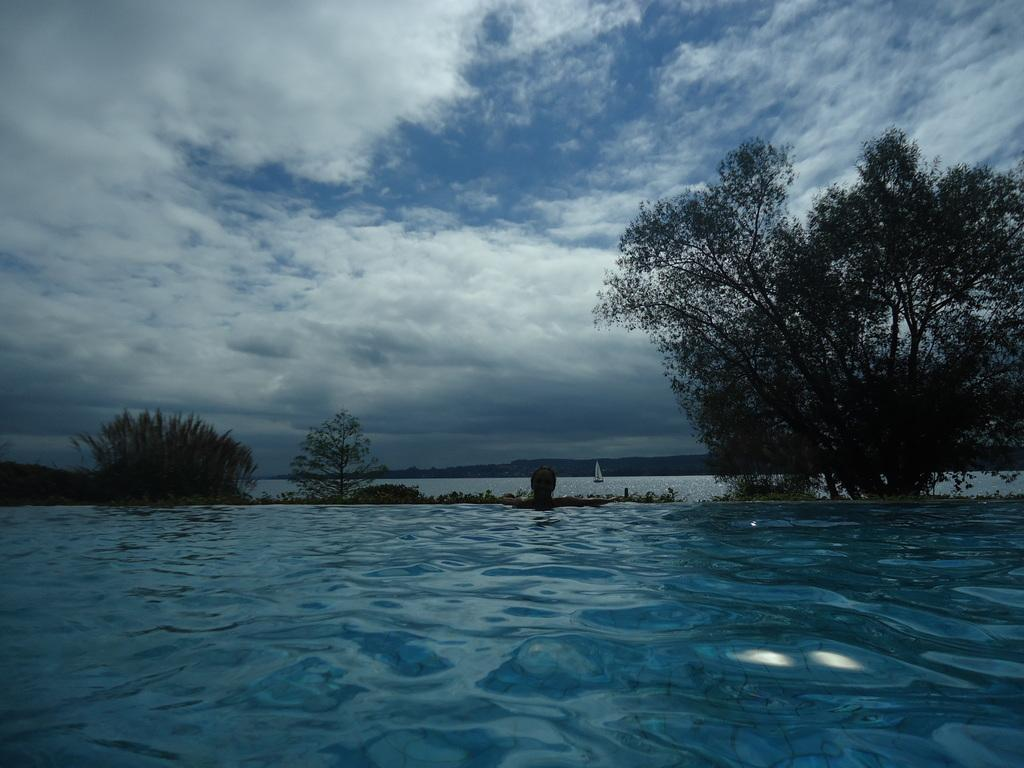What is the main element in the picture? There is water in the picture. What can be seen near the water? There are trees in the picture. What is floating on the water? There is a boat on the water. What is visible in the sky? Clouds are visible in the sky. What type of soup can be seen in the boat in the image? There is no soup present in the image; it features water, trees, a boat, and clouds. Can you describe the brain of the person operating the boat in the image? There is no person or brain visible in the image; it only shows water, trees, a boat, and clouds. 